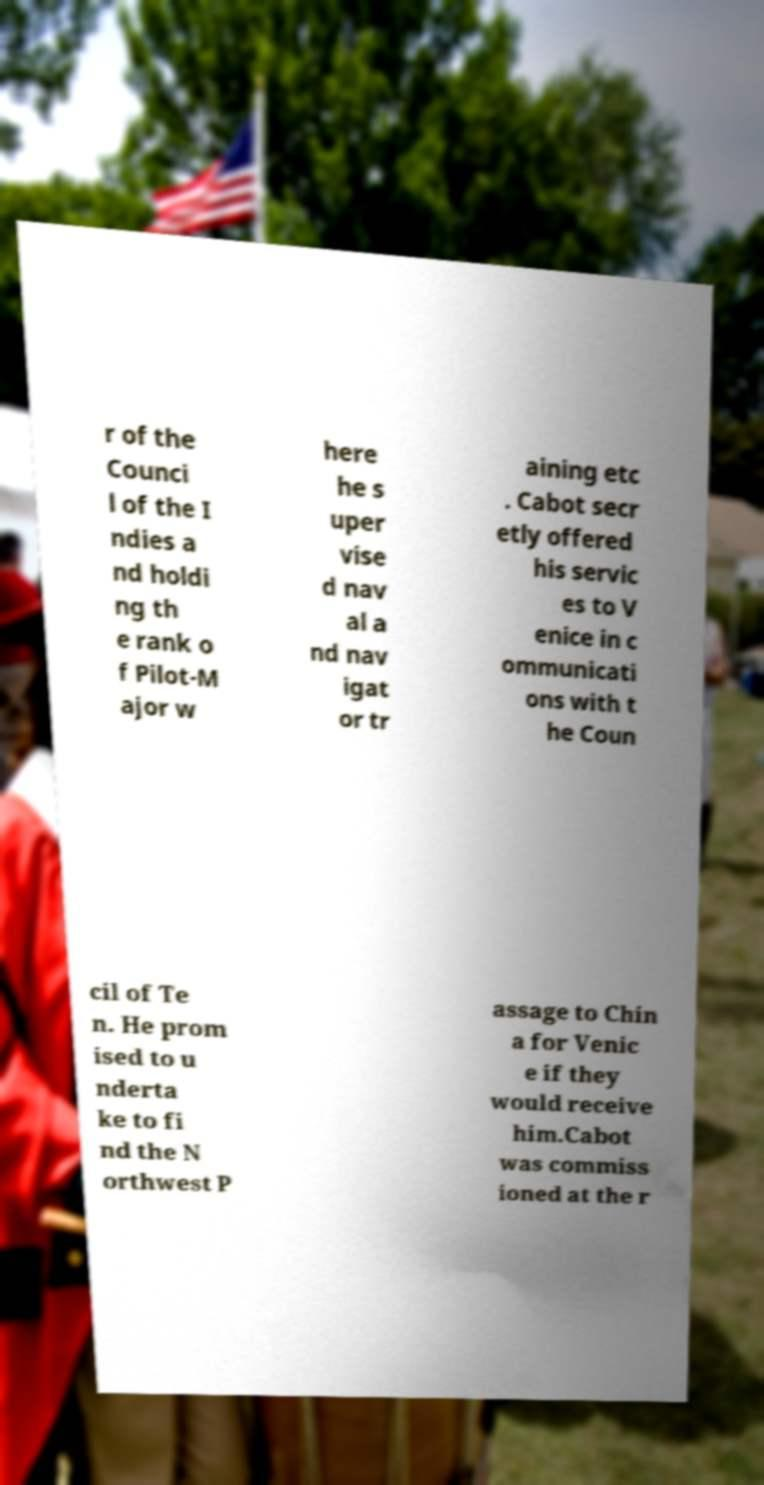For documentation purposes, I need the text within this image transcribed. Could you provide that? r of the Counci l of the I ndies a nd holdi ng th e rank o f Pilot-M ajor w here he s uper vise d nav al a nd nav igat or tr aining etc . Cabot secr etly offered his servic es to V enice in c ommunicati ons with t he Coun cil of Te n. He prom ised to u nderta ke to fi nd the N orthwest P assage to Chin a for Venic e if they would receive him.Cabot was commiss ioned at the r 